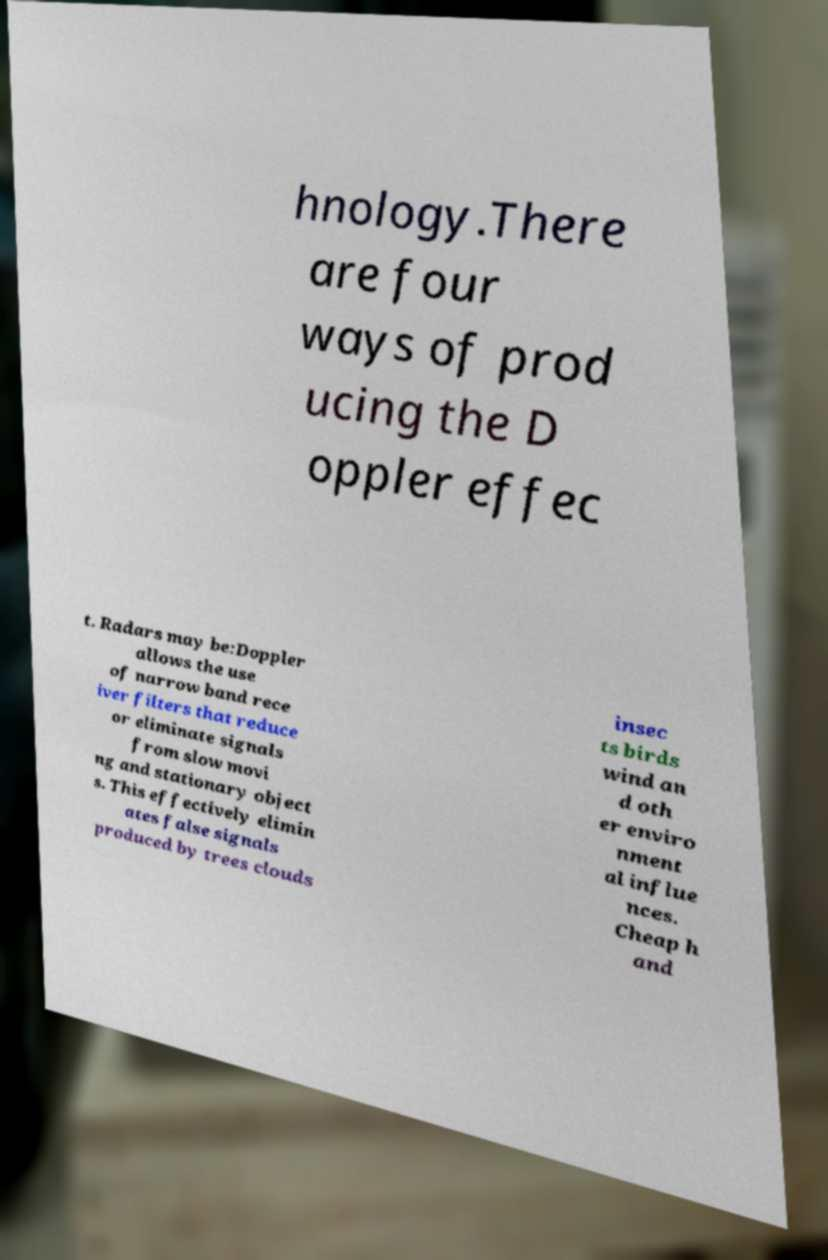Please identify and transcribe the text found in this image. hnology.There are four ways of prod ucing the D oppler effec t. Radars may be:Doppler allows the use of narrow band rece iver filters that reduce or eliminate signals from slow movi ng and stationary object s. This effectively elimin ates false signals produced by trees clouds insec ts birds wind an d oth er enviro nment al influe nces. Cheap h and 